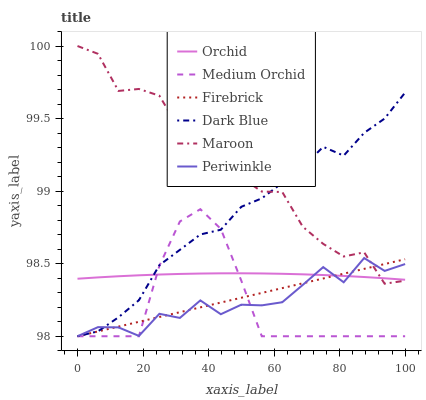Does Medium Orchid have the minimum area under the curve?
Answer yes or no. Yes. Does Maroon have the maximum area under the curve?
Answer yes or no. Yes. Does Maroon have the minimum area under the curve?
Answer yes or no. No. Does Medium Orchid have the maximum area under the curve?
Answer yes or no. No. Is Firebrick the smoothest?
Answer yes or no. Yes. Is Maroon the roughest?
Answer yes or no. Yes. Is Medium Orchid the smoothest?
Answer yes or no. No. Is Medium Orchid the roughest?
Answer yes or no. No. Does Firebrick have the lowest value?
Answer yes or no. Yes. Does Maroon have the lowest value?
Answer yes or no. No. Does Maroon have the highest value?
Answer yes or no. Yes. Does Medium Orchid have the highest value?
Answer yes or no. No. Is Medium Orchid less than Maroon?
Answer yes or no. Yes. Is Maroon greater than Medium Orchid?
Answer yes or no. Yes. Does Dark Blue intersect Maroon?
Answer yes or no. Yes. Is Dark Blue less than Maroon?
Answer yes or no. No. Is Dark Blue greater than Maroon?
Answer yes or no. No. Does Medium Orchid intersect Maroon?
Answer yes or no. No. 